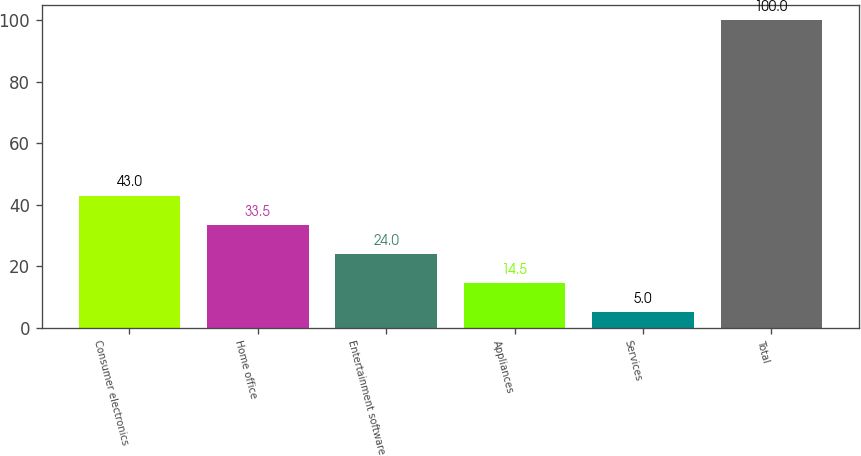Convert chart to OTSL. <chart><loc_0><loc_0><loc_500><loc_500><bar_chart><fcel>Consumer electronics<fcel>Home office<fcel>Entertainment software<fcel>Appliances<fcel>Services<fcel>Total<nl><fcel>43<fcel>33.5<fcel>24<fcel>14.5<fcel>5<fcel>100<nl></chart> 